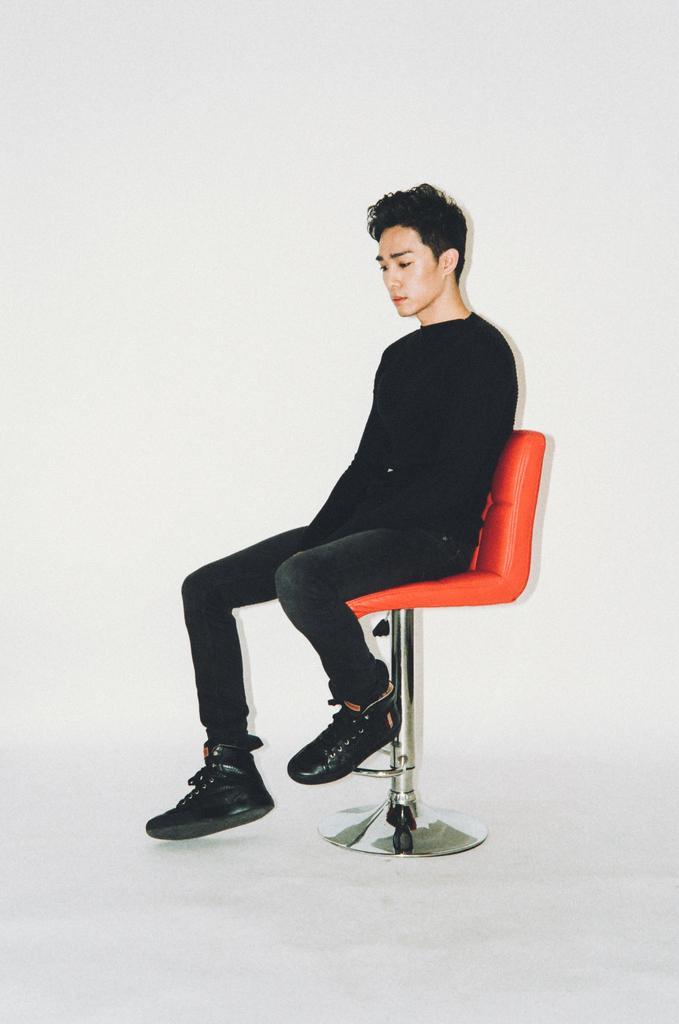Please provide a concise description of this image. In the center of the image, we can see a person sitting on the chair and the background is in white color. 